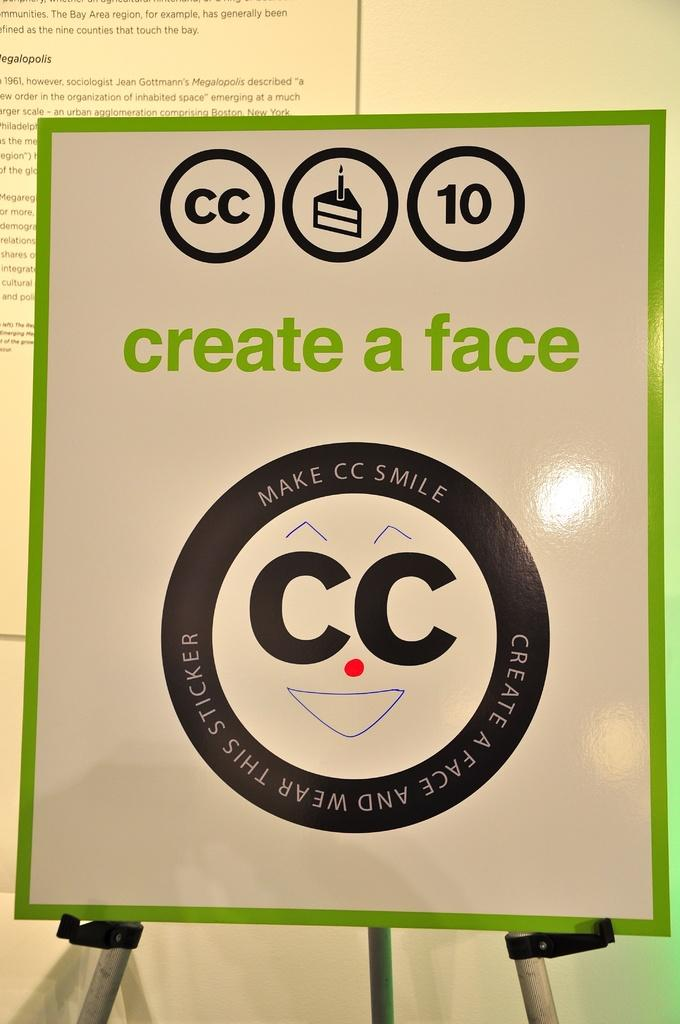What can be seen in the image that contains written information? There is written text in the image. Can you describe the appearance of the text in the image? The text is in different colors. Where is the grandfather mentioned in the image? There is no mention of a grandfather in the image. 